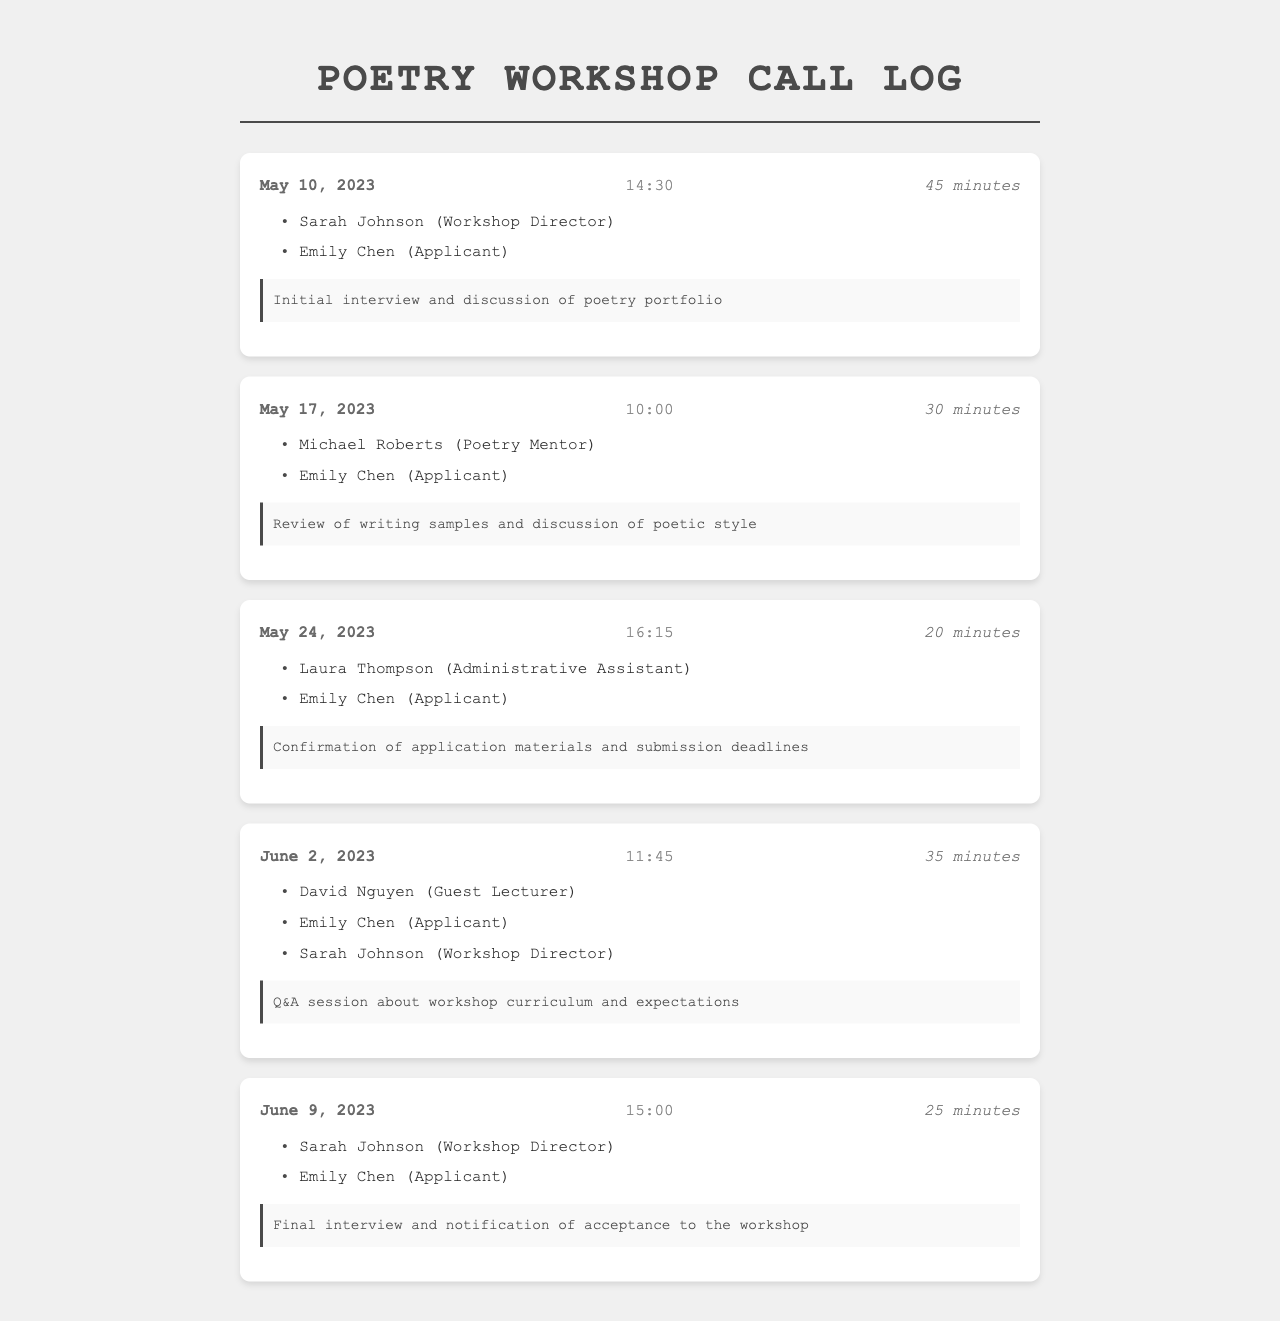what was the date of the first call? The date of the first call is listed in the document as May 10, 2023.
Answer: May 10, 2023 who participated in the last call? The last call included Sarah Johnson, Emily Chen, and their roles are mentioned in the call logs.
Answer: Sarah Johnson (Workshop Director), Emily Chen (Applicant) how long was the second call? The document states that the second call had a duration of 30 minutes.
Answer: 30 minutes what was discussed in the call on June 2, 2023? The notes for the call on June 2, 2023 indicate that it was a Q&A session about workshop curriculum and expectations.
Answer: Q&A session about workshop curriculum and expectations who is the workshop director? The document identifies Sarah Johnson as the Workshop Director in multiple call logs.
Answer: Sarah Johnson how many calls included Emily Chen as a participant? Upon reviewing the document, there are a total of five calls that included Emily Chen as a participant.
Answer: 5 what was the duration of the call on May 24, 2023? The duration of the call is explicitly noted in the call log, which is 20 minutes.
Answer: 20 minutes what type of notes were taken during the first call? The notes section indicates that the first call was about an initial interview and discussion of the poetry portfolio.
Answer: Initial interview and discussion of poetry portfolio how many participants were on the call on June 2, 2023? The document states that three participants were present during the call on June 2, 2023.
Answer: 3 